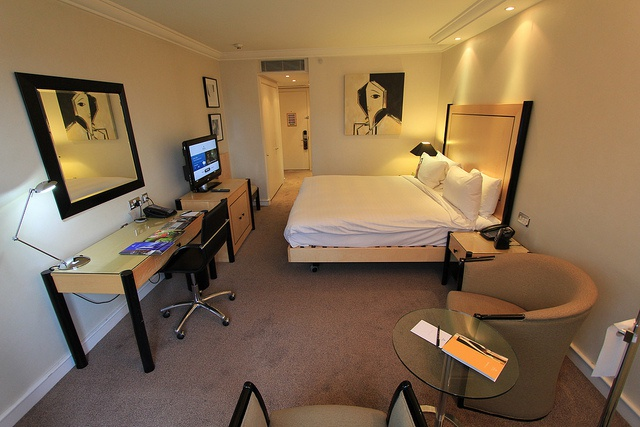Describe the objects in this image and their specific colors. I can see bed in olive, tan, and darkgray tones, chair in olive, maroon, brown, and black tones, couch in olive, maroon, brown, and black tones, couch in olive, gray, black, and brown tones, and chair in olive, gray, black, and brown tones in this image. 